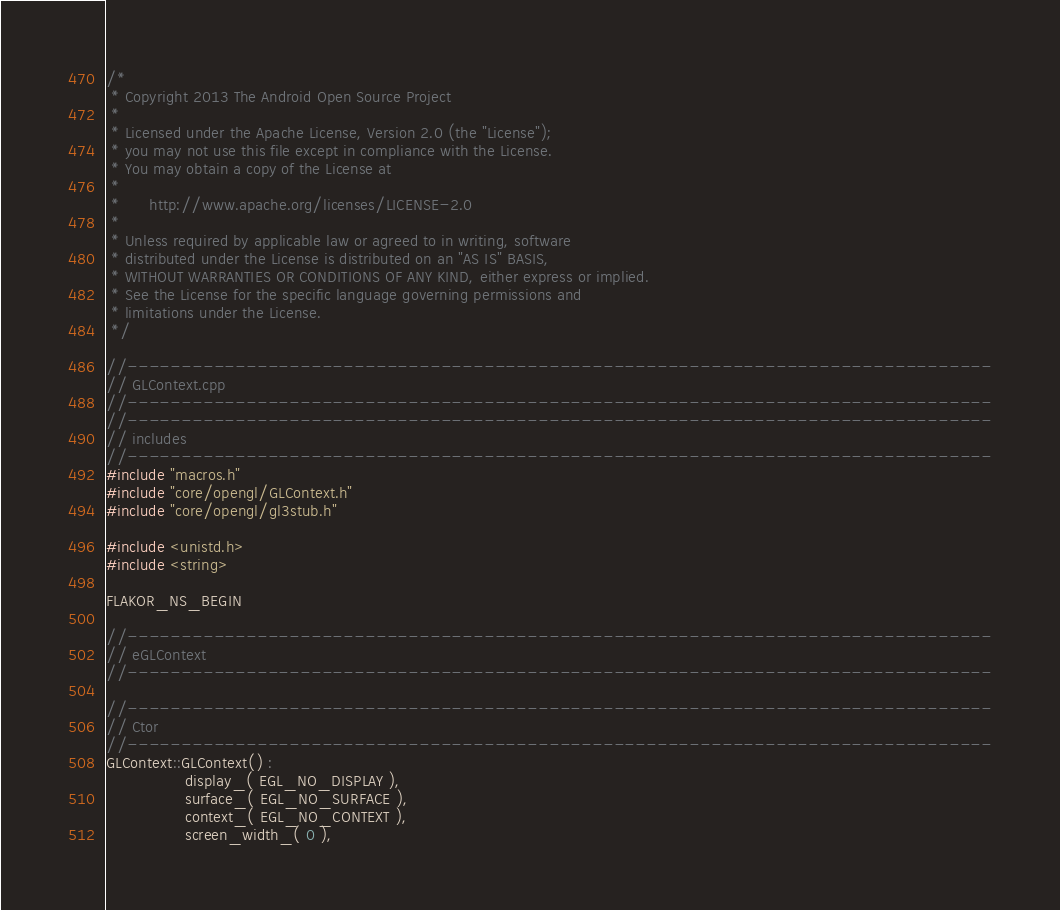<code> <loc_0><loc_0><loc_500><loc_500><_C++_>/*
 * Copyright 2013 The Android Open Source Project
 *
 * Licensed under the Apache License, Version 2.0 (the "License");
 * you may not use this file except in compliance with the License.
 * You may obtain a copy of the License at
 *
 *      http://www.apache.org/licenses/LICENSE-2.0
 *
 * Unless required by applicable law or agreed to in writing, software
 * distributed under the License is distributed on an "AS IS" BASIS,
 * WITHOUT WARRANTIES OR CONDITIONS OF ANY KIND, either express or implied.
 * See the License for the specific language governing permissions and
 * limitations under the License.
 */

//--------------------------------------------------------------------------------
// GLContext.cpp
//--------------------------------------------------------------------------------
//--------------------------------------------------------------------------------
// includes
//--------------------------------------------------------------------------------
#include "macros.h"
#include "core/opengl/GLContext.h"
#include "core/opengl/gl3stub.h"

#include <unistd.h>
#include <string>

FLAKOR_NS_BEGIN

//--------------------------------------------------------------------------------
// eGLContext
//--------------------------------------------------------------------------------

//--------------------------------------------------------------------------------
// Ctor
//--------------------------------------------------------------------------------
GLContext::GLContext() :
                display_( EGL_NO_DISPLAY ),
                surface_( EGL_NO_SURFACE ),
                context_( EGL_NO_CONTEXT ),
                screen_width_( 0 ),</code> 